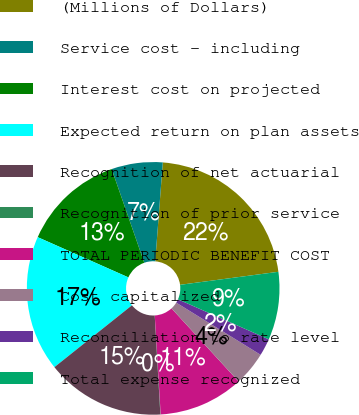<chart> <loc_0><loc_0><loc_500><loc_500><pie_chart><fcel>(Millions of Dollars)<fcel>Service cost - including<fcel>Interest cost on projected<fcel>Expected return on plan assets<fcel>Recognition of net actuarial<fcel>Recognition of prior service<fcel>TOTAL PERIODIC BENEFIT COST<fcel>Cost capitalized<fcel>Reconciliation to rate level<fcel>Total expense recognized<nl><fcel>21.69%<fcel>6.54%<fcel>13.03%<fcel>17.36%<fcel>15.19%<fcel>0.04%<fcel>10.87%<fcel>4.37%<fcel>2.21%<fcel>8.7%<nl></chart> 